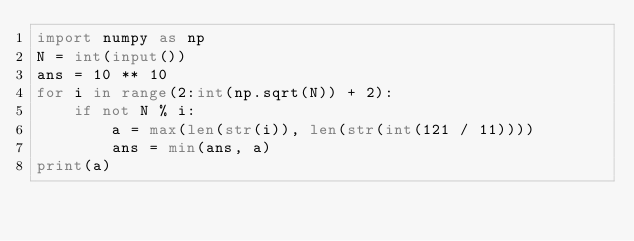Convert code to text. <code><loc_0><loc_0><loc_500><loc_500><_Python_>import numpy as np
N = int(input())
ans = 10 ** 10
for i in range(2:int(np.sqrt(N)) + 2):
    if not N % i:
        a = max(len(str(i)), len(str(int(121 / 11))))
        ans = min(ans, a)
print(a)</code> 